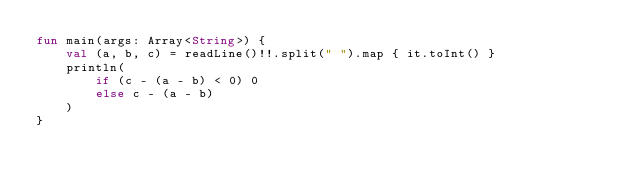<code> <loc_0><loc_0><loc_500><loc_500><_Kotlin_>fun main(args: Array<String>) {
    val (a, b, c) = readLine()!!.split(" ").map { it.toInt() }
    println(
        if (c - (a - b) < 0) 0
        else c - (a - b)
    )
}</code> 